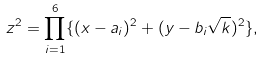Convert formula to latex. <formula><loc_0><loc_0><loc_500><loc_500>z ^ { 2 } = \prod _ { i = 1 } ^ { 6 } \{ ( x - a _ { i } ) ^ { 2 } + ( y - b _ { i } \sqrt { k } ) ^ { 2 } \} ,</formula> 